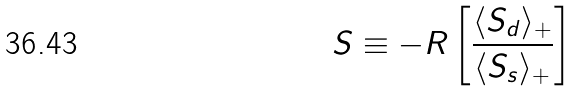<formula> <loc_0><loc_0><loc_500><loc_500>S \equiv - R \left [ \frac { \langle S _ { d } \rangle _ { + } } { \langle S _ { s } \rangle _ { + } } \right ]</formula> 